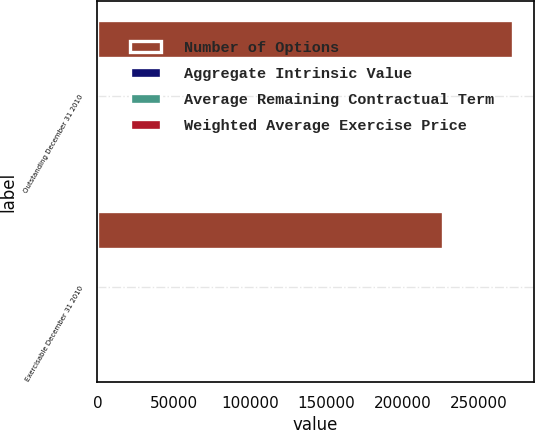Convert chart. <chart><loc_0><loc_0><loc_500><loc_500><stacked_bar_chart><ecel><fcel>Outstanding December 31 2010<fcel>Exercisable December 31 2010<nl><fcel>Number of Options<fcel>272241<fcel>226231<nl><fcel>Aggregate Intrinsic Value<fcel>42.26<fcel>44.56<nl><fcel>Average Remaining Contractual Term<fcel>4.47<fcel>3.83<nl><fcel>Weighted Average Exercise Price<fcel>771<fcel>469<nl></chart> 